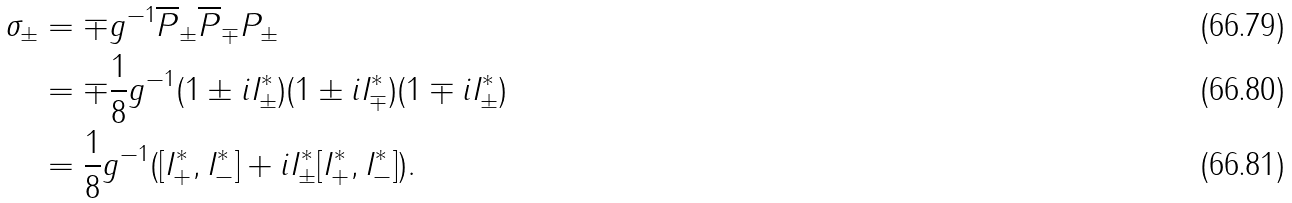<formula> <loc_0><loc_0><loc_500><loc_500>\sigma _ { \pm } & = \mp g ^ { - 1 } \overline { P } _ { \pm } \overline { P } _ { \mp } P _ { \pm } \\ & = \mp \frac { 1 } { 8 } g ^ { - 1 } ( 1 \pm i I ^ { * } _ { \pm } ) ( 1 \pm i I ^ { * } _ { \mp } ) ( 1 \mp i I ^ { * } _ { \pm } ) \\ & = \frac { 1 } { 8 } g ^ { - 1 } ( [ I ^ { * } _ { + } , I ^ { * } _ { - } ] + i I ^ { * } _ { \pm } [ I ^ { * } _ { + } , I ^ { * } _ { - } ] ) .</formula> 